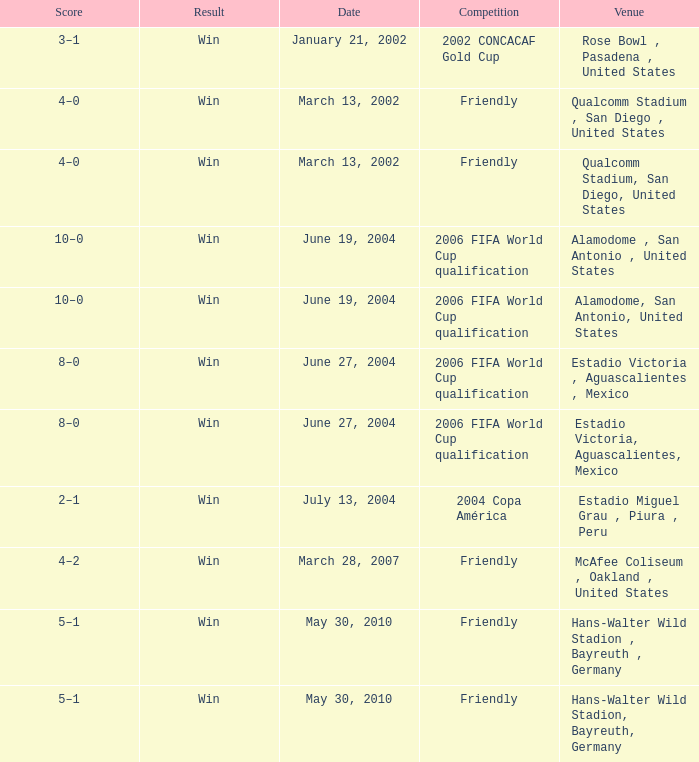What date has 2006 fifa world cup qualification as the competition, and alamodome, san antonio, united States as the venue? June 19, 2004, June 19, 2004. 